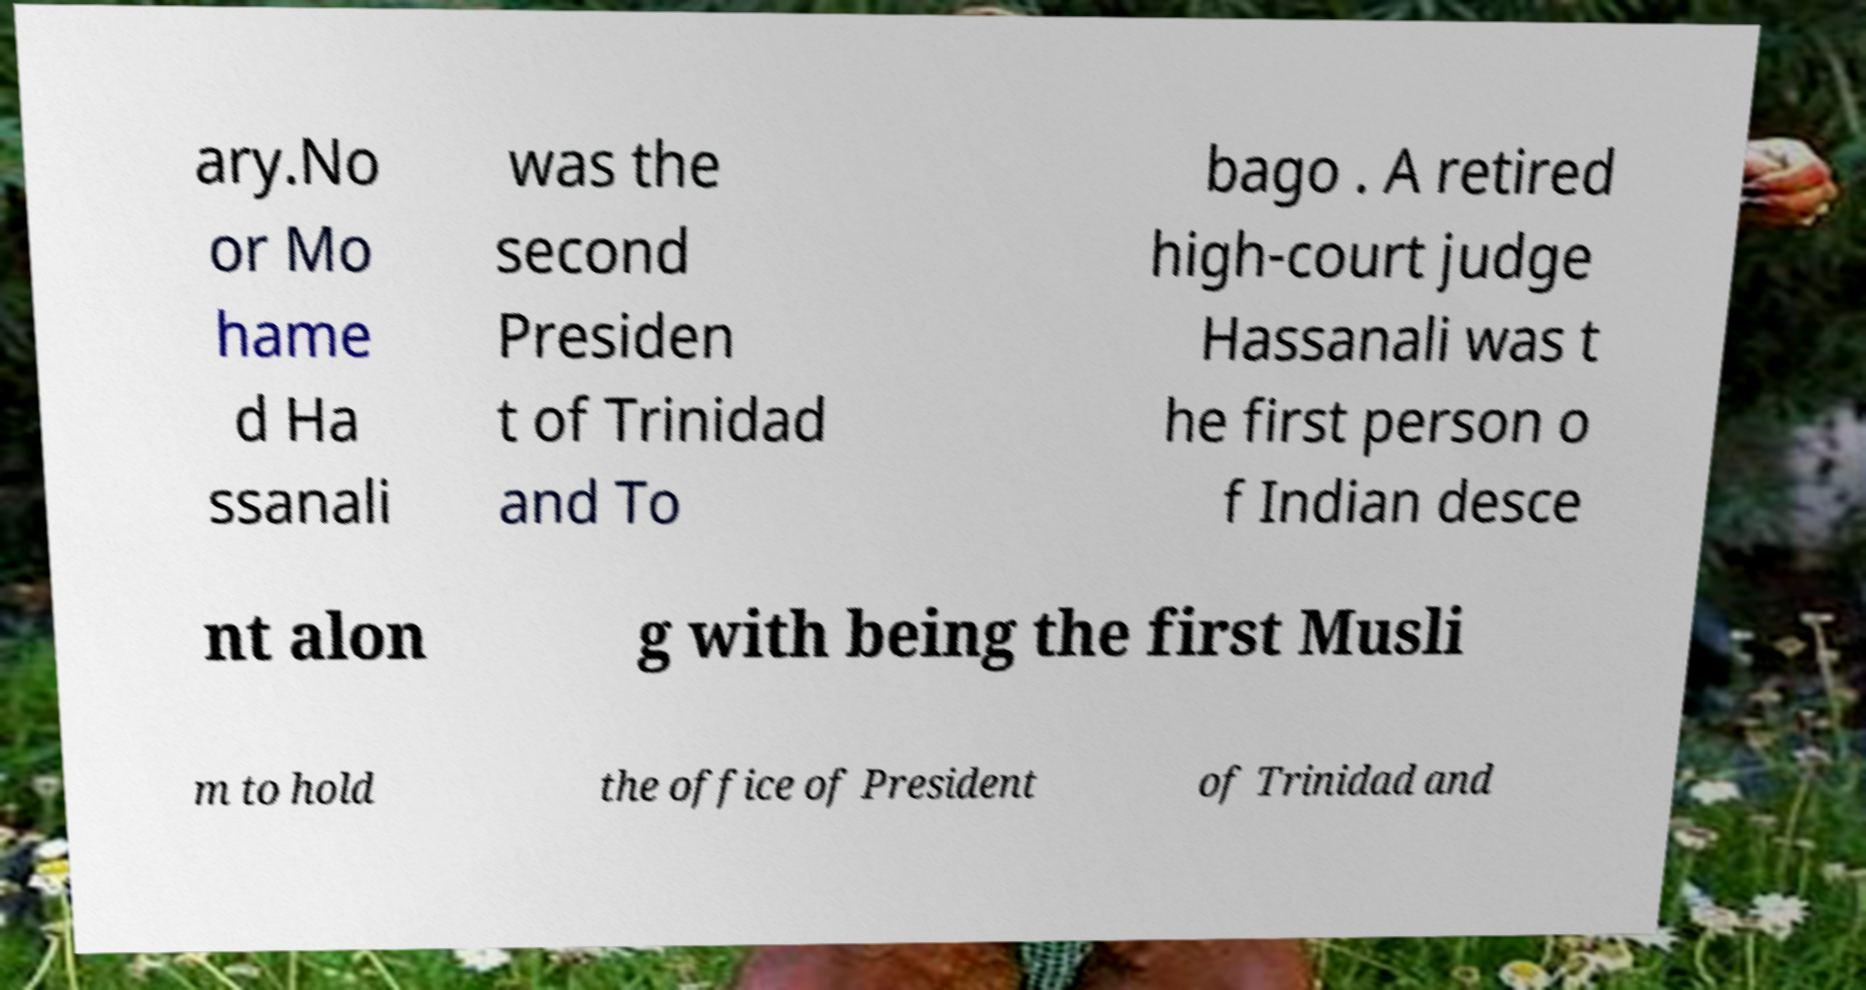I need the written content from this picture converted into text. Can you do that? ary.No or Mo hame d Ha ssanali was the second Presiden t of Trinidad and To bago . A retired high-court judge Hassanali was t he first person o f Indian desce nt alon g with being the first Musli m to hold the office of President of Trinidad and 